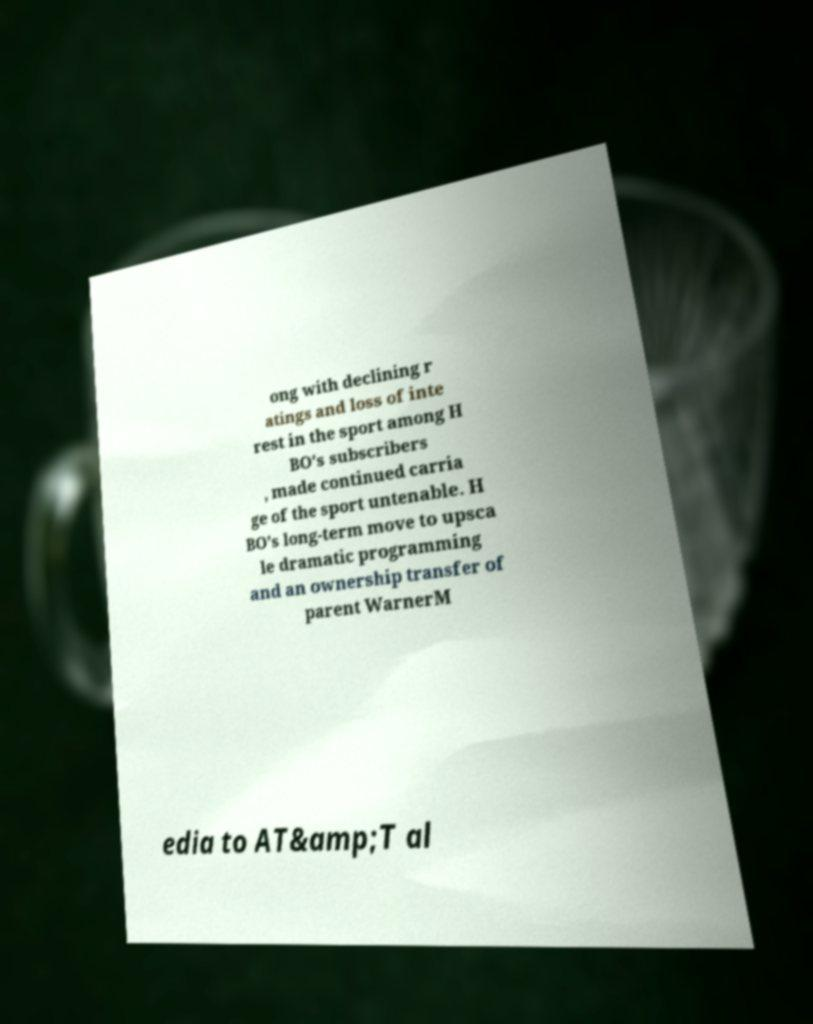I need the written content from this picture converted into text. Can you do that? ong with declining r atings and loss of inte rest in the sport among H BO's subscribers , made continued carria ge of the sport untenable. H BO's long-term move to upsca le dramatic programming and an ownership transfer of parent WarnerM edia to AT&amp;T al 